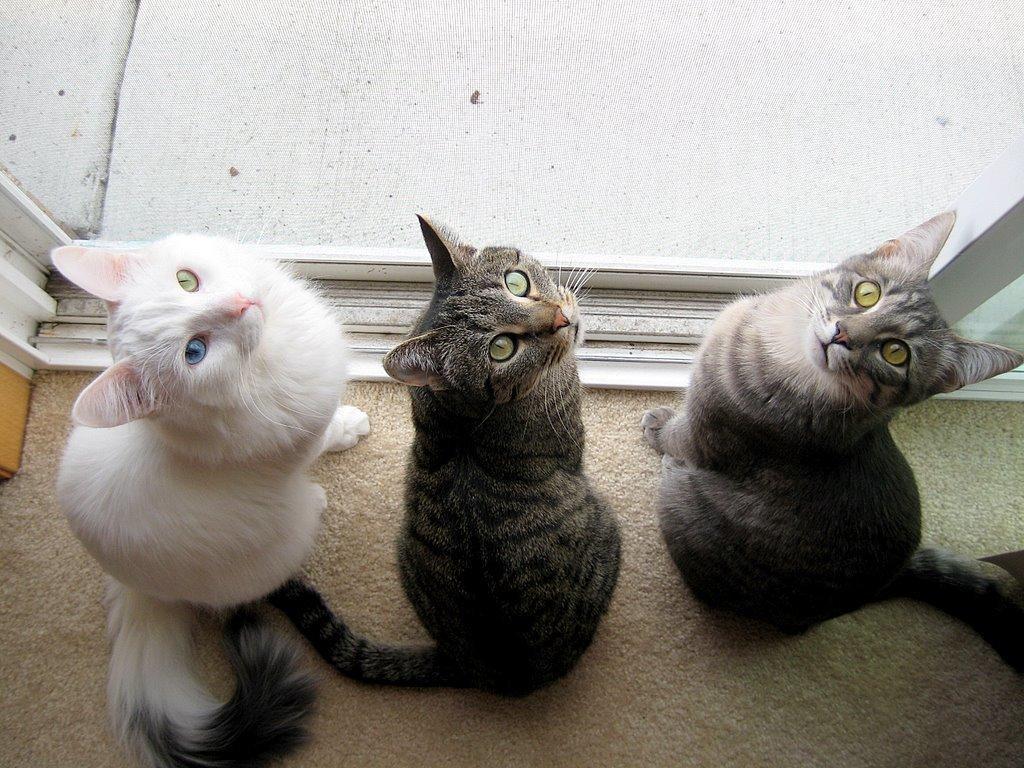Could you give a brief overview of what you see in this image? In this image there are three cats on the carpet. 